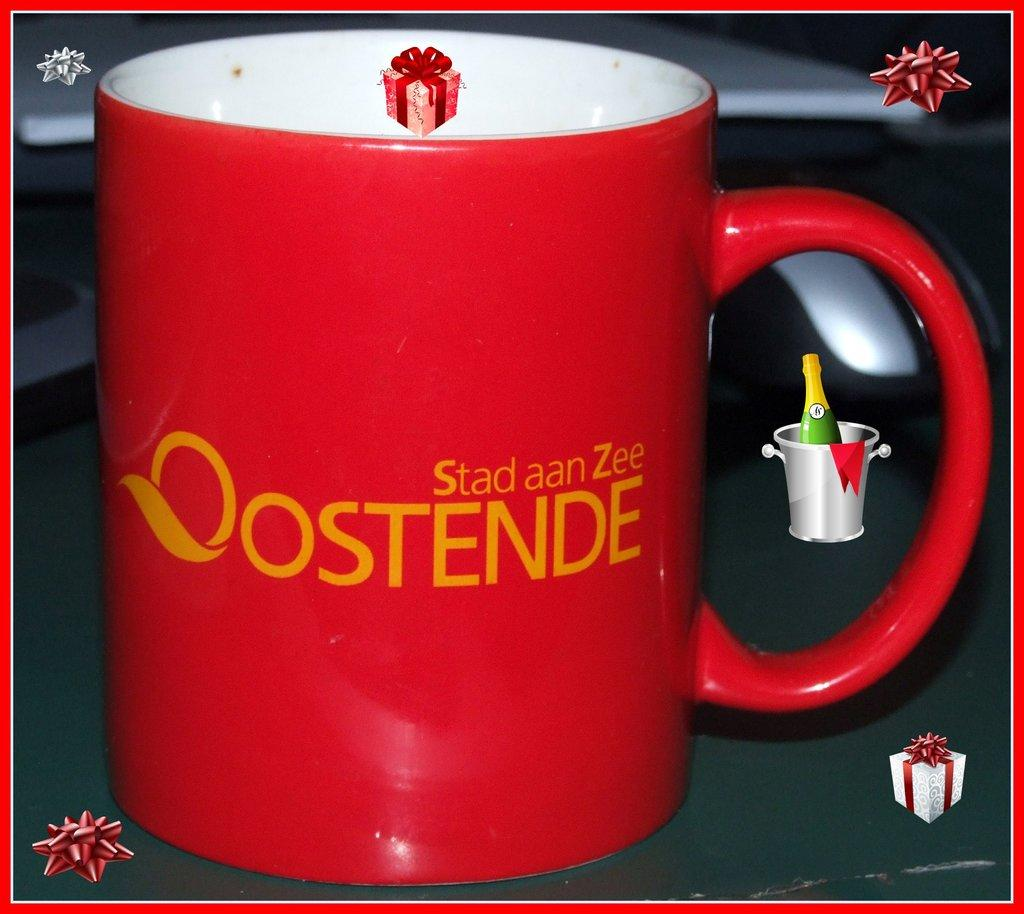<image>
Write a terse but informative summary of the picture. A red mug sathing Stad aan Zee Oostende is surrounded by little holiday images. 